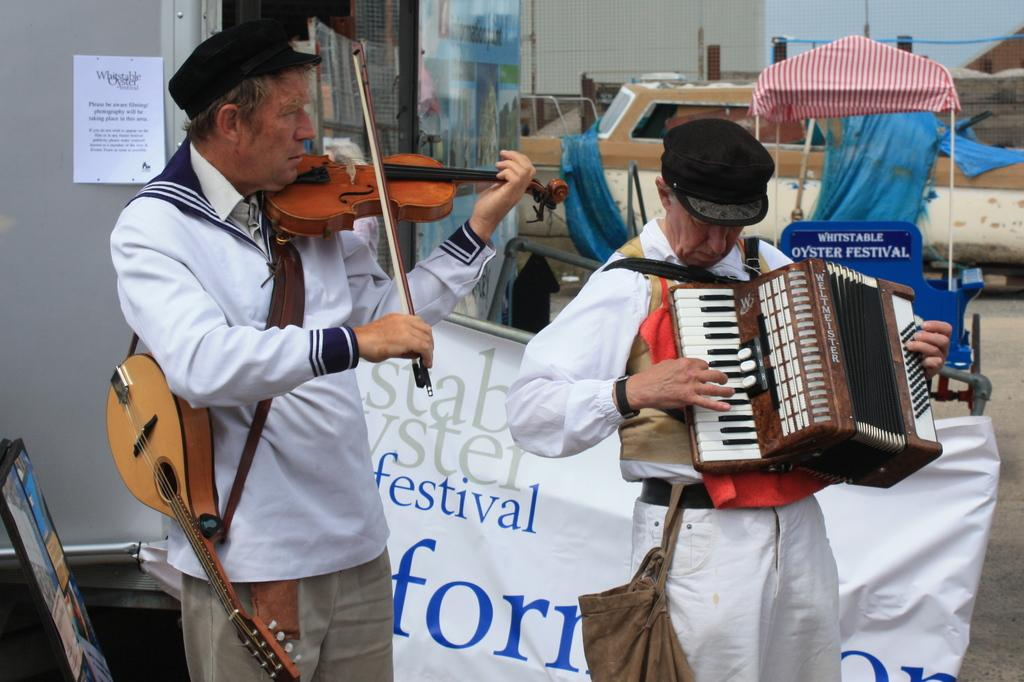How many people are in the image? There are two persons in the image. What are the persons doing in the image? The persons are playing musical instruments. What can be seen in the background of the image? There is a building in the background of the image. What type of branch is the daughter holding in the image? There is no daughter or branch present in the image. How many strings are visible on the musical instruments in the image? The provided facts do not mention the number of strings on the musical instruments, so it cannot be determined from the image. 